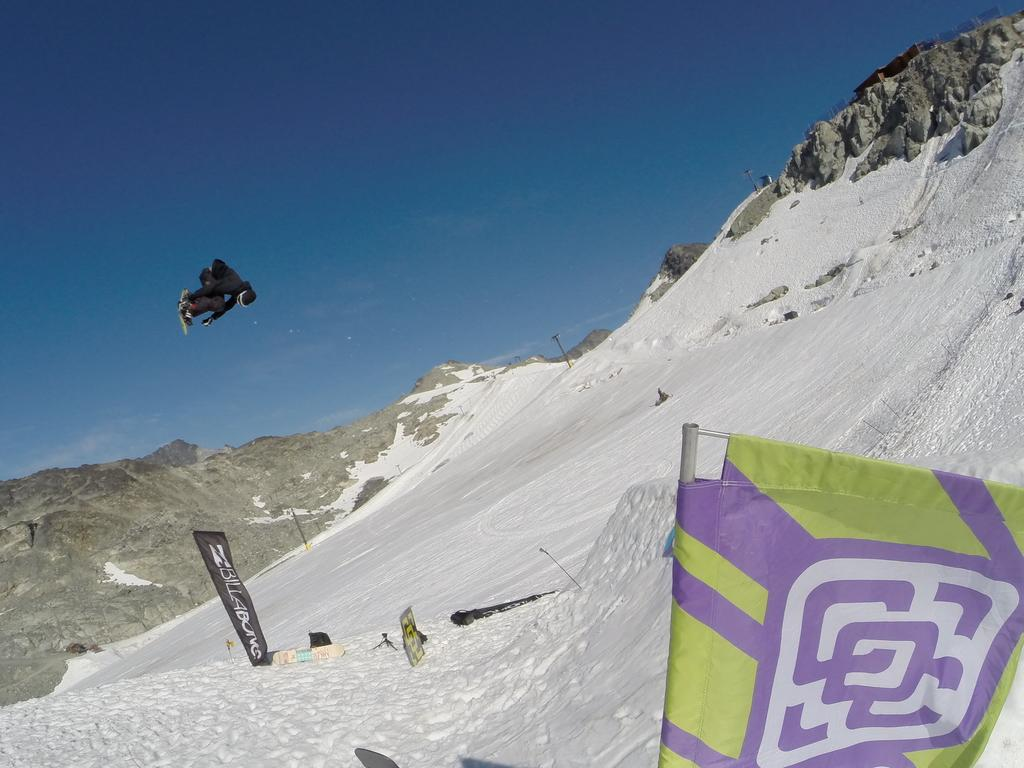What type of advertisements can be seen in the image? There are hoardings in the image. What type of sports equipment is visible in the image? There are skateboards in the image. What type of structures can be seen in the image? There are poles in the image. What is present on the snow in the image? There are other things on the snow in the image. Can you describe the person in the image? The person in the image is in the air. What is the person in the image feeling, specifically anger? There is no indication of the person's emotions in the image, so it cannot be determined if they are feeling anger. What type of bike can be seen in the image? There is no bike present in the image. 